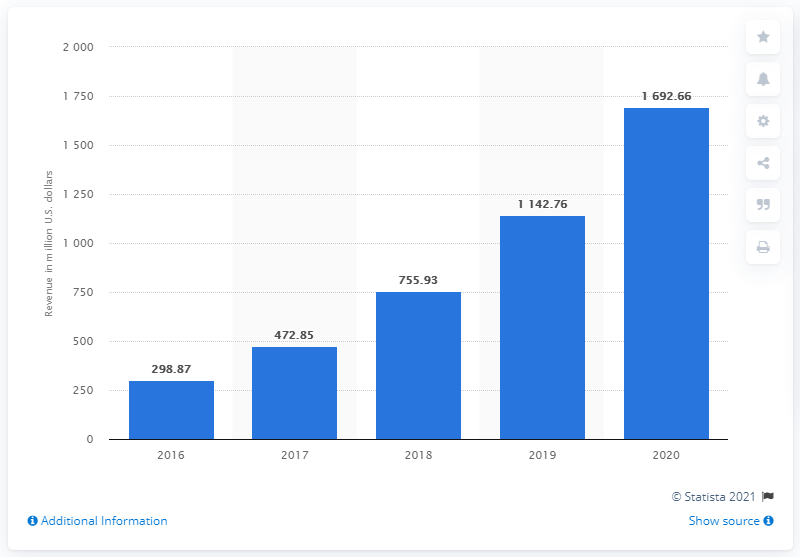Identify some key points in this picture. Pinterest generated approximately $1692.66 million in revenue in 2020. Pinterest's revenue in the previous year was 1142.76 million dollars. 